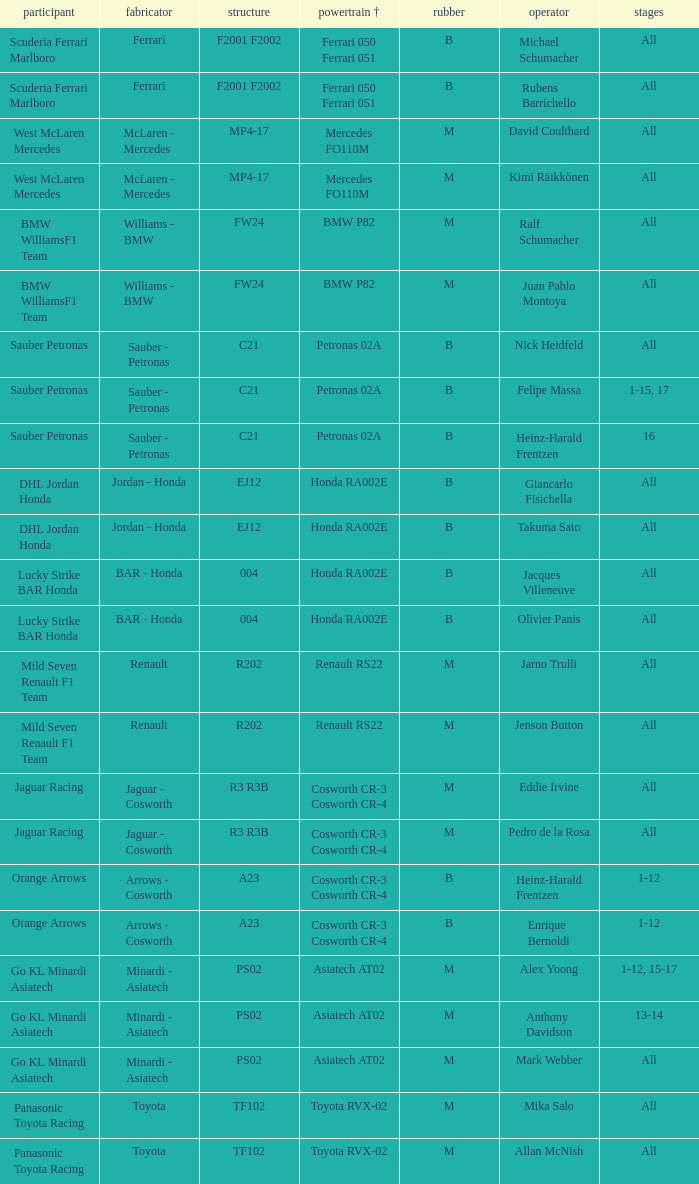What is the rounds when the engine is mercedes fo110m? All, All. 